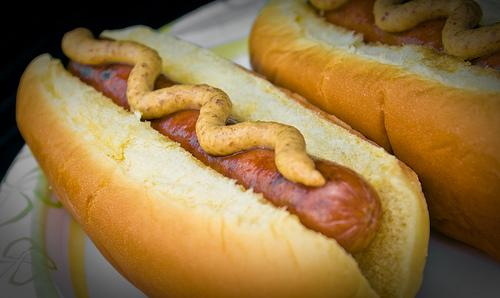Answer the question: What kind of mustard can be seen on the hot dogs? Stone ground yellow mustard, applied in a squiggle line pattern. Which pair of objects would provide the most information for a multi-choice VQA task? Squiggle line of mustard and green design on paper plate. Imagine you are advertising the hot dogs in the image. Write a catchy slogan. Savor the Flavor: Grilled Franks Loaded with Tangy Mustard! The Ultimate Taste Sensation Awaits! Describe the relationship between the hot dogs and the plate in the image, focusing on their positions. Two hot dogs are arranged in their buns, placed side-by-side on a round white paper plate with green and yellow designs on its edge. Create a brief advertisement text for the hot dogs in the image, focusing on their appearance and attributes. Introducing our Perfectly Grilled Hot Dogs: Delightfully Juicy, with Tantalizing Grill Marks, Nestled in Fluffy White Buns, and Drizzled in our Signature Stone Ground Yellow Mustard! Taste the Difference Today! Based on the given objects in the image, determine what the main objects are for the visual entailment task. Hot dogs with mustard, white paper plate, and grilled hot dog on bun. Describe two key details for the referential expression grounding task based on the image. The hot dog in a bun with mustard and the white paper plate with yellow and green designs. Select the main elements present in the image. Hot dogs with mustard on buns, white paper plate with green and yellow designs, grill marks on hot dogs, stone ground yellow mustard, and brown crease in hot dog bun. What can be inferred from the image about the composition of the plate? The plate is white, presumably made of paper, and decorated with green and yellow patterns or designs, likely held or served as disposable dishware. Propose a multiple-choice question for a VQA task based on the image. Correct answer: The hot dogs have grill marks on them. 